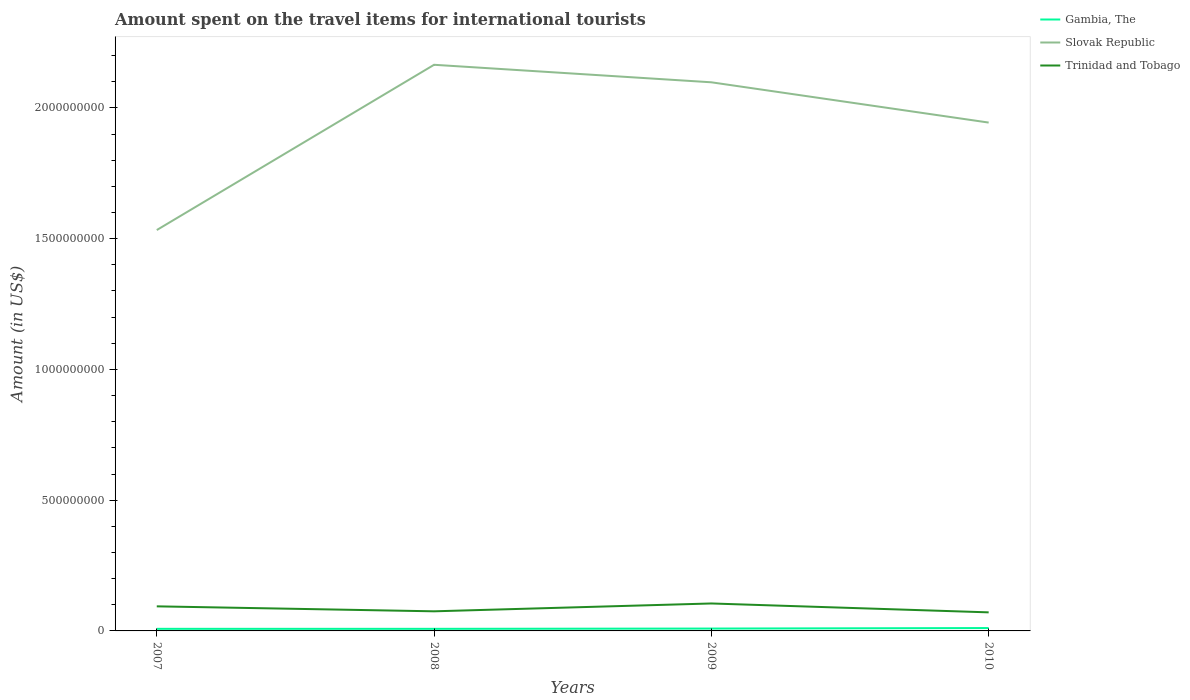Does the line corresponding to Slovak Republic intersect with the line corresponding to Gambia, The?
Offer a very short reply. No. Across all years, what is the maximum amount spent on the travel items for international tourists in Slovak Republic?
Provide a short and direct response. 1.53e+09. What is the total amount spent on the travel items for international tourists in Slovak Republic in the graph?
Keep it short and to the point. 1.54e+08. What is the difference between the highest and the second highest amount spent on the travel items for international tourists in Trinidad and Tobago?
Ensure brevity in your answer.  3.40e+07. What is the difference between the highest and the lowest amount spent on the travel items for international tourists in Trinidad and Tobago?
Make the answer very short. 2. What is the difference between two consecutive major ticks on the Y-axis?
Offer a terse response. 5.00e+08. Are the values on the major ticks of Y-axis written in scientific E-notation?
Your answer should be compact. No. How are the legend labels stacked?
Your answer should be compact. Vertical. What is the title of the graph?
Provide a succinct answer. Amount spent on the travel items for international tourists. What is the label or title of the Y-axis?
Ensure brevity in your answer.  Amount (in US$). What is the Amount (in US$) in Slovak Republic in 2007?
Give a very brief answer. 1.53e+09. What is the Amount (in US$) of Trinidad and Tobago in 2007?
Offer a terse response. 9.40e+07. What is the Amount (in US$) in Slovak Republic in 2008?
Your answer should be compact. 2.16e+09. What is the Amount (in US$) of Trinidad and Tobago in 2008?
Ensure brevity in your answer.  7.50e+07. What is the Amount (in US$) of Gambia, The in 2009?
Give a very brief answer. 9.00e+06. What is the Amount (in US$) in Slovak Republic in 2009?
Ensure brevity in your answer.  2.10e+09. What is the Amount (in US$) in Trinidad and Tobago in 2009?
Give a very brief answer. 1.05e+08. What is the Amount (in US$) of Gambia, The in 2010?
Offer a terse response. 1.10e+07. What is the Amount (in US$) in Slovak Republic in 2010?
Offer a very short reply. 1.94e+09. What is the Amount (in US$) in Trinidad and Tobago in 2010?
Keep it short and to the point. 7.10e+07. Across all years, what is the maximum Amount (in US$) in Gambia, The?
Give a very brief answer. 1.10e+07. Across all years, what is the maximum Amount (in US$) of Slovak Republic?
Ensure brevity in your answer.  2.16e+09. Across all years, what is the maximum Amount (in US$) in Trinidad and Tobago?
Offer a terse response. 1.05e+08. Across all years, what is the minimum Amount (in US$) in Gambia, The?
Your answer should be compact. 8.00e+06. Across all years, what is the minimum Amount (in US$) of Slovak Republic?
Offer a terse response. 1.53e+09. Across all years, what is the minimum Amount (in US$) of Trinidad and Tobago?
Make the answer very short. 7.10e+07. What is the total Amount (in US$) in Gambia, The in the graph?
Give a very brief answer. 3.60e+07. What is the total Amount (in US$) of Slovak Republic in the graph?
Provide a short and direct response. 7.74e+09. What is the total Amount (in US$) of Trinidad and Tobago in the graph?
Your answer should be very brief. 3.45e+08. What is the difference between the Amount (in US$) in Slovak Republic in 2007 and that in 2008?
Your answer should be compact. -6.32e+08. What is the difference between the Amount (in US$) of Trinidad and Tobago in 2007 and that in 2008?
Offer a terse response. 1.90e+07. What is the difference between the Amount (in US$) of Gambia, The in 2007 and that in 2009?
Ensure brevity in your answer.  -1.00e+06. What is the difference between the Amount (in US$) of Slovak Republic in 2007 and that in 2009?
Your answer should be compact. -5.65e+08. What is the difference between the Amount (in US$) of Trinidad and Tobago in 2007 and that in 2009?
Provide a short and direct response. -1.10e+07. What is the difference between the Amount (in US$) in Slovak Republic in 2007 and that in 2010?
Provide a succinct answer. -4.11e+08. What is the difference between the Amount (in US$) in Trinidad and Tobago in 2007 and that in 2010?
Your answer should be very brief. 2.30e+07. What is the difference between the Amount (in US$) in Slovak Republic in 2008 and that in 2009?
Your response must be concise. 6.70e+07. What is the difference between the Amount (in US$) in Trinidad and Tobago in 2008 and that in 2009?
Ensure brevity in your answer.  -3.00e+07. What is the difference between the Amount (in US$) in Gambia, The in 2008 and that in 2010?
Your answer should be compact. -3.00e+06. What is the difference between the Amount (in US$) of Slovak Republic in 2008 and that in 2010?
Your response must be concise. 2.21e+08. What is the difference between the Amount (in US$) in Slovak Republic in 2009 and that in 2010?
Offer a terse response. 1.54e+08. What is the difference between the Amount (in US$) of Trinidad and Tobago in 2009 and that in 2010?
Make the answer very short. 3.40e+07. What is the difference between the Amount (in US$) in Gambia, The in 2007 and the Amount (in US$) in Slovak Republic in 2008?
Ensure brevity in your answer.  -2.16e+09. What is the difference between the Amount (in US$) in Gambia, The in 2007 and the Amount (in US$) in Trinidad and Tobago in 2008?
Keep it short and to the point. -6.70e+07. What is the difference between the Amount (in US$) of Slovak Republic in 2007 and the Amount (in US$) of Trinidad and Tobago in 2008?
Provide a short and direct response. 1.46e+09. What is the difference between the Amount (in US$) in Gambia, The in 2007 and the Amount (in US$) in Slovak Republic in 2009?
Your answer should be compact. -2.09e+09. What is the difference between the Amount (in US$) in Gambia, The in 2007 and the Amount (in US$) in Trinidad and Tobago in 2009?
Your answer should be compact. -9.70e+07. What is the difference between the Amount (in US$) of Slovak Republic in 2007 and the Amount (in US$) of Trinidad and Tobago in 2009?
Give a very brief answer. 1.43e+09. What is the difference between the Amount (in US$) of Gambia, The in 2007 and the Amount (in US$) of Slovak Republic in 2010?
Your answer should be very brief. -1.94e+09. What is the difference between the Amount (in US$) in Gambia, The in 2007 and the Amount (in US$) in Trinidad and Tobago in 2010?
Make the answer very short. -6.30e+07. What is the difference between the Amount (in US$) in Slovak Republic in 2007 and the Amount (in US$) in Trinidad and Tobago in 2010?
Your answer should be very brief. 1.46e+09. What is the difference between the Amount (in US$) in Gambia, The in 2008 and the Amount (in US$) in Slovak Republic in 2009?
Give a very brief answer. -2.09e+09. What is the difference between the Amount (in US$) in Gambia, The in 2008 and the Amount (in US$) in Trinidad and Tobago in 2009?
Your answer should be compact. -9.70e+07. What is the difference between the Amount (in US$) of Slovak Republic in 2008 and the Amount (in US$) of Trinidad and Tobago in 2009?
Provide a succinct answer. 2.06e+09. What is the difference between the Amount (in US$) in Gambia, The in 2008 and the Amount (in US$) in Slovak Republic in 2010?
Provide a succinct answer. -1.94e+09. What is the difference between the Amount (in US$) in Gambia, The in 2008 and the Amount (in US$) in Trinidad and Tobago in 2010?
Give a very brief answer. -6.30e+07. What is the difference between the Amount (in US$) in Slovak Republic in 2008 and the Amount (in US$) in Trinidad and Tobago in 2010?
Your response must be concise. 2.09e+09. What is the difference between the Amount (in US$) of Gambia, The in 2009 and the Amount (in US$) of Slovak Republic in 2010?
Offer a terse response. -1.94e+09. What is the difference between the Amount (in US$) of Gambia, The in 2009 and the Amount (in US$) of Trinidad and Tobago in 2010?
Make the answer very short. -6.20e+07. What is the difference between the Amount (in US$) in Slovak Republic in 2009 and the Amount (in US$) in Trinidad and Tobago in 2010?
Your answer should be compact. 2.03e+09. What is the average Amount (in US$) of Gambia, The per year?
Your answer should be compact. 9.00e+06. What is the average Amount (in US$) of Slovak Republic per year?
Your answer should be compact. 1.94e+09. What is the average Amount (in US$) of Trinidad and Tobago per year?
Provide a short and direct response. 8.62e+07. In the year 2007, what is the difference between the Amount (in US$) of Gambia, The and Amount (in US$) of Slovak Republic?
Offer a very short reply. -1.52e+09. In the year 2007, what is the difference between the Amount (in US$) of Gambia, The and Amount (in US$) of Trinidad and Tobago?
Provide a succinct answer. -8.60e+07. In the year 2007, what is the difference between the Amount (in US$) in Slovak Republic and Amount (in US$) in Trinidad and Tobago?
Provide a succinct answer. 1.44e+09. In the year 2008, what is the difference between the Amount (in US$) in Gambia, The and Amount (in US$) in Slovak Republic?
Offer a very short reply. -2.16e+09. In the year 2008, what is the difference between the Amount (in US$) in Gambia, The and Amount (in US$) in Trinidad and Tobago?
Offer a very short reply. -6.70e+07. In the year 2008, what is the difference between the Amount (in US$) in Slovak Republic and Amount (in US$) in Trinidad and Tobago?
Your answer should be very brief. 2.09e+09. In the year 2009, what is the difference between the Amount (in US$) in Gambia, The and Amount (in US$) in Slovak Republic?
Your answer should be compact. -2.09e+09. In the year 2009, what is the difference between the Amount (in US$) of Gambia, The and Amount (in US$) of Trinidad and Tobago?
Give a very brief answer. -9.60e+07. In the year 2009, what is the difference between the Amount (in US$) in Slovak Republic and Amount (in US$) in Trinidad and Tobago?
Provide a short and direct response. 1.99e+09. In the year 2010, what is the difference between the Amount (in US$) of Gambia, The and Amount (in US$) of Slovak Republic?
Your answer should be compact. -1.93e+09. In the year 2010, what is the difference between the Amount (in US$) of Gambia, The and Amount (in US$) of Trinidad and Tobago?
Your answer should be compact. -6.00e+07. In the year 2010, what is the difference between the Amount (in US$) in Slovak Republic and Amount (in US$) in Trinidad and Tobago?
Provide a short and direct response. 1.87e+09. What is the ratio of the Amount (in US$) in Gambia, The in 2007 to that in 2008?
Offer a terse response. 1. What is the ratio of the Amount (in US$) of Slovak Republic in 2007 to that in 2008?
Your response must be concise. 0.71. What is the ratio of the Amount (in US$) in Trinidad and Tobago in 2007 to that in 2008?
Offer a very short reply. 1.25. What is the ratio of the Amount (in US$) in Slovak Republic in 2007 to that in 2009?
Make the answer very short. 0.73. What is the ratio of the Amount (in US$) of Trinidad and Tobago in 2007 to that in 2009?
Your answer should be compact. 0.9. What is the ratio of the Amount (in US$) in Gambia, The in 2007 to that in 2010?
Offer a very short reply. 0.73. What is the ratio of the Amount (in US$) in Slovak Republic in 2007 to that in 2010?
Offer a very short reply. 0.79. What is the ratio of the Amount (in US$) of Trinidad and Tobago in 2007 to that in 2010?
Keep it short and to the point. 1.32. What is the ratio of the Amount (in US$) in Slovak Republic in 2008 to that in 2009?
Your answer should be very brief. 1.03. What is the ratio of the Amount (in US$) in Trinidad and Tobago in 2008 to that in 2009?
Give a very brief answer. 0.71. What is the ratio of the Amount (in US$) of Gambia, The in 2008 to that in 2010?
Your answer should be compact. 0.73. What is the ratio of the Amount (in US$) of Slovak Republic in 2008 to that in 2010?
Your response must be concise. 1.11. What is the ratio of the Amount (in US$) in Trinidad and Tobago in 2008 to that in 2010?
Provide a succinct answer. 1.06. What is the ratio of the Amount (in US$) of Gambia, The in 2009 to that in 2010?
Offer a very short reply. 0.82. What is the ratio of the Amount (in US$) in Slovak Republic in 2009 to that in 2010?
Offer a terse response. 1.08. What is the ratio of the Amount (in US$) of Trinidad and Tobago in 2009 to that in 2010?
Ensure brevity in your answer.  1.48. What is the difference between the highest and the second highest Amount (in US$) of Slovak Republic?
Offer a very short reply. 6.70e+07. What is the difference between the highest and the second highest Amount (in US$) of Trinidad and Tobago?
Your answer should be compact. 1.10e+07. What is the difference between the highest and the lowest Amount (in US$) in Gambia, The?
Offer a terse response. 3.00e+06. What is the difference between the highest and the lowest Amount (in US$) of Slovak Republic?
Keep it short and to the point. 6.32e+08. What is the difference between the highest and the lowest Amount (in US$) of Trinidad and Tobago?
Provide a short and direct response. 3.40e+07. 